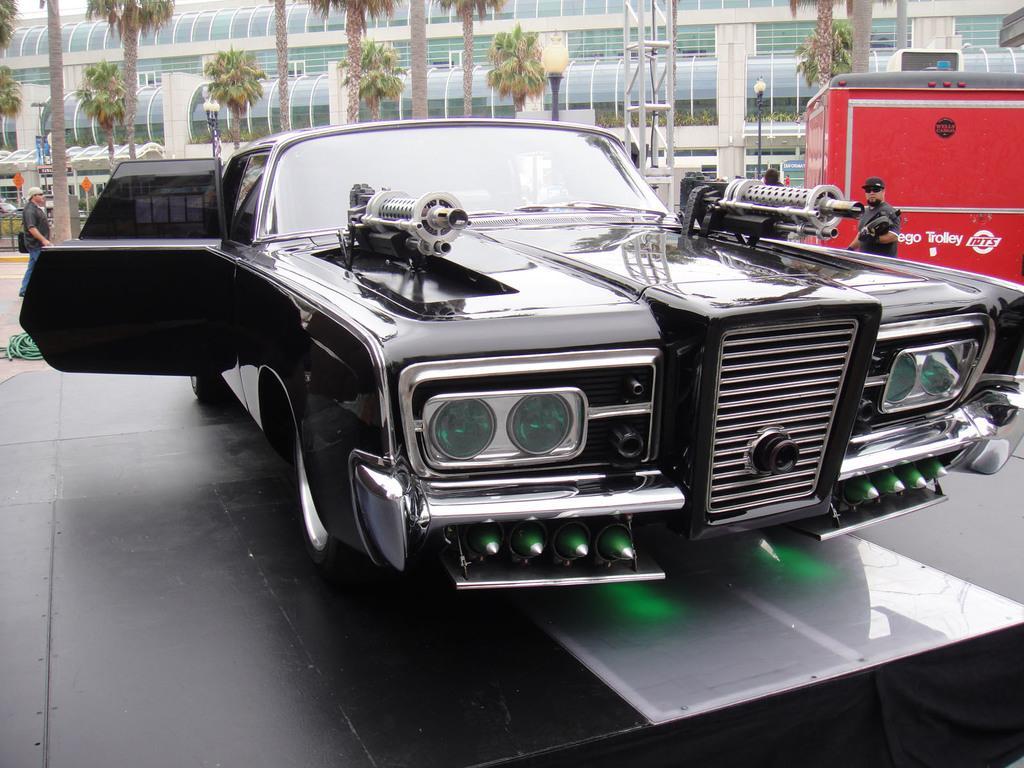In one or two sentences, can you explain what this image depicts? This is a car, which is black in color. I think these are the weapons, which are attached to a car. Here is a person standing. This looks like another vehicle, which is red in color. I can see the light poles. These are the trees. This looks like a building with the glass doors. On the left side of the image, I can see another person standing. 